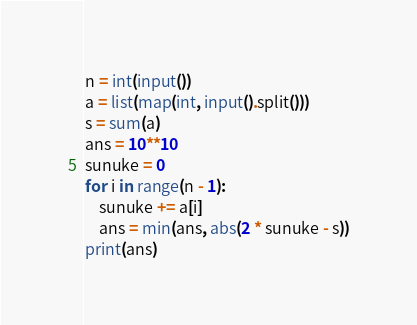Convert code to text. <code><loc_0><loc_0><loc_500><loc_500><_Python_>n = int(input())
a = list(map(int, input().split()))
s = sum(a)
ans = 10**10
sunuke = 0
for i in range(n - 1):
    sunuke += a[i]
    ans = min(ans, abs(2 * sunuke - s))
print(ans)
</code> 